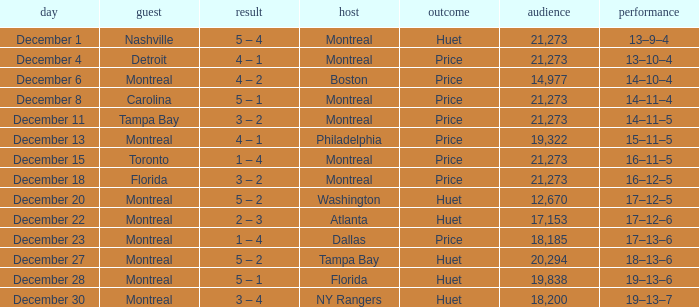What is the score when Philadelphia is at home? 4 – 1. 